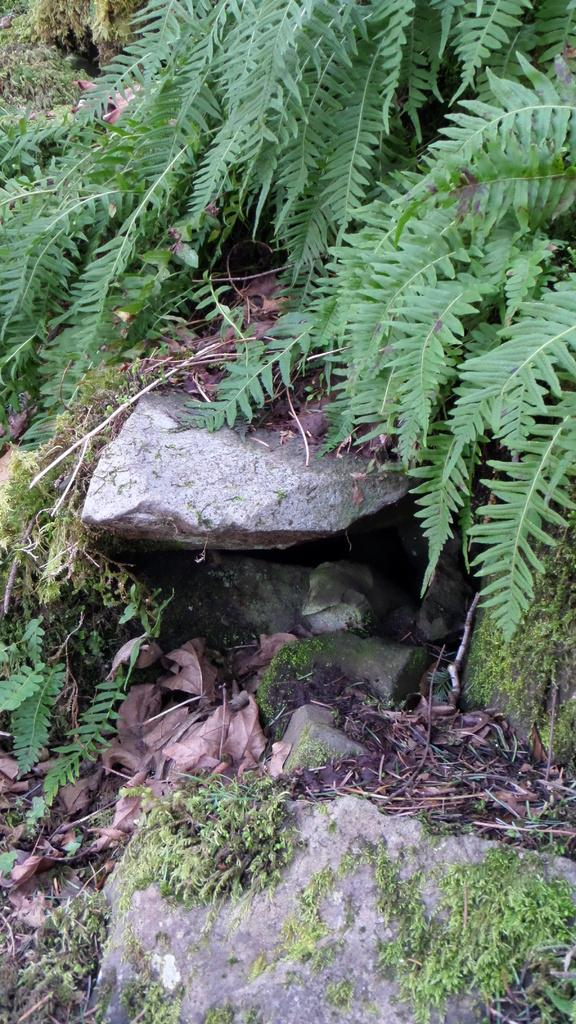What type of living organisms can be seen in the image? Plants can be seen in the image. What other objects are present in the image besides plants? There are rocks in the image. What can be found in the center of the image? There are dry leaves in the center of the image. What type of drum can be seen in the image? There is no drum present in the image. What prose is written on the rocks in the image? There is no prose written on the rocks in the image. 